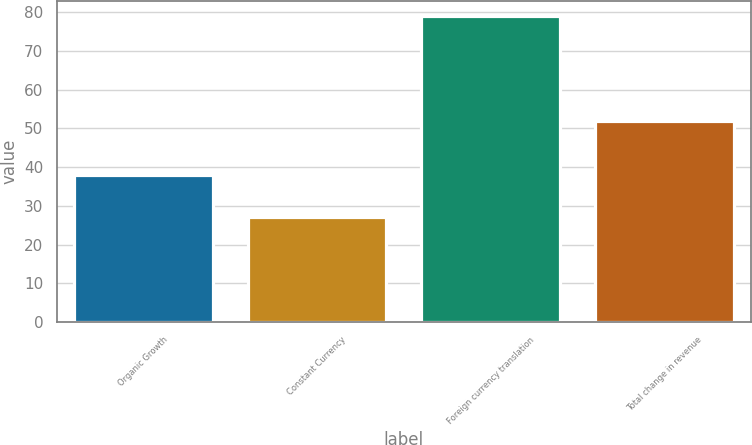Convert chart to OTSL. <chart><loc_0><loc_0><loc_500><loc_500><bar_chart><fcel>Organic Growth<fcel>Constant Currency<fcel>Foreign currency translation<fcel>Total change in revenue<nl><fcel>38<fcel>27<fcel>79<fcel>52<nl></chart> 